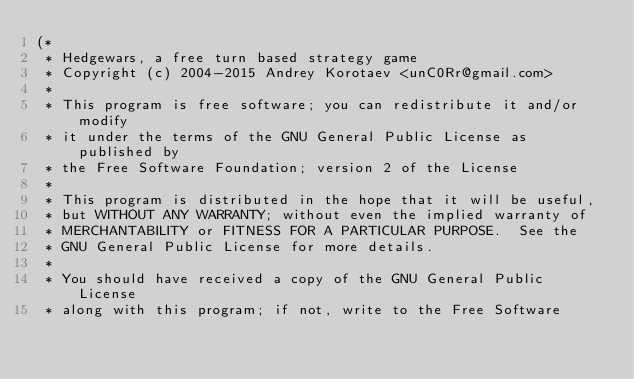Convert code to text. <code><loc_0><loc_0><loc_500><loc_500><_Pascal_>(*
 * Hedgewars, a free turn based strategy game
 * Copyright (c) 2004-2015 Andrey Korotaev <unC0Rr@gmail.com>
 *
 * This program is free software; you can redistribute it and/or modify
 * it under the terms of the GNU General Public License as published by
 * the Free Software Foundation; version 2 of the License
 *
 * This program is distributed in the hope that it will be useful,
 * but WITHOUT ANY WARRANTY; without even the implied warranty of
 * MERCHANTABILITY or FITNESS FOR A PARTICULAR PURPOSE.  See the
 * GNU General Public License for more details.
 *
 * You should have received a copy of the GNU General Public License
 * along with this program; if not, write to the Free Software</code> 